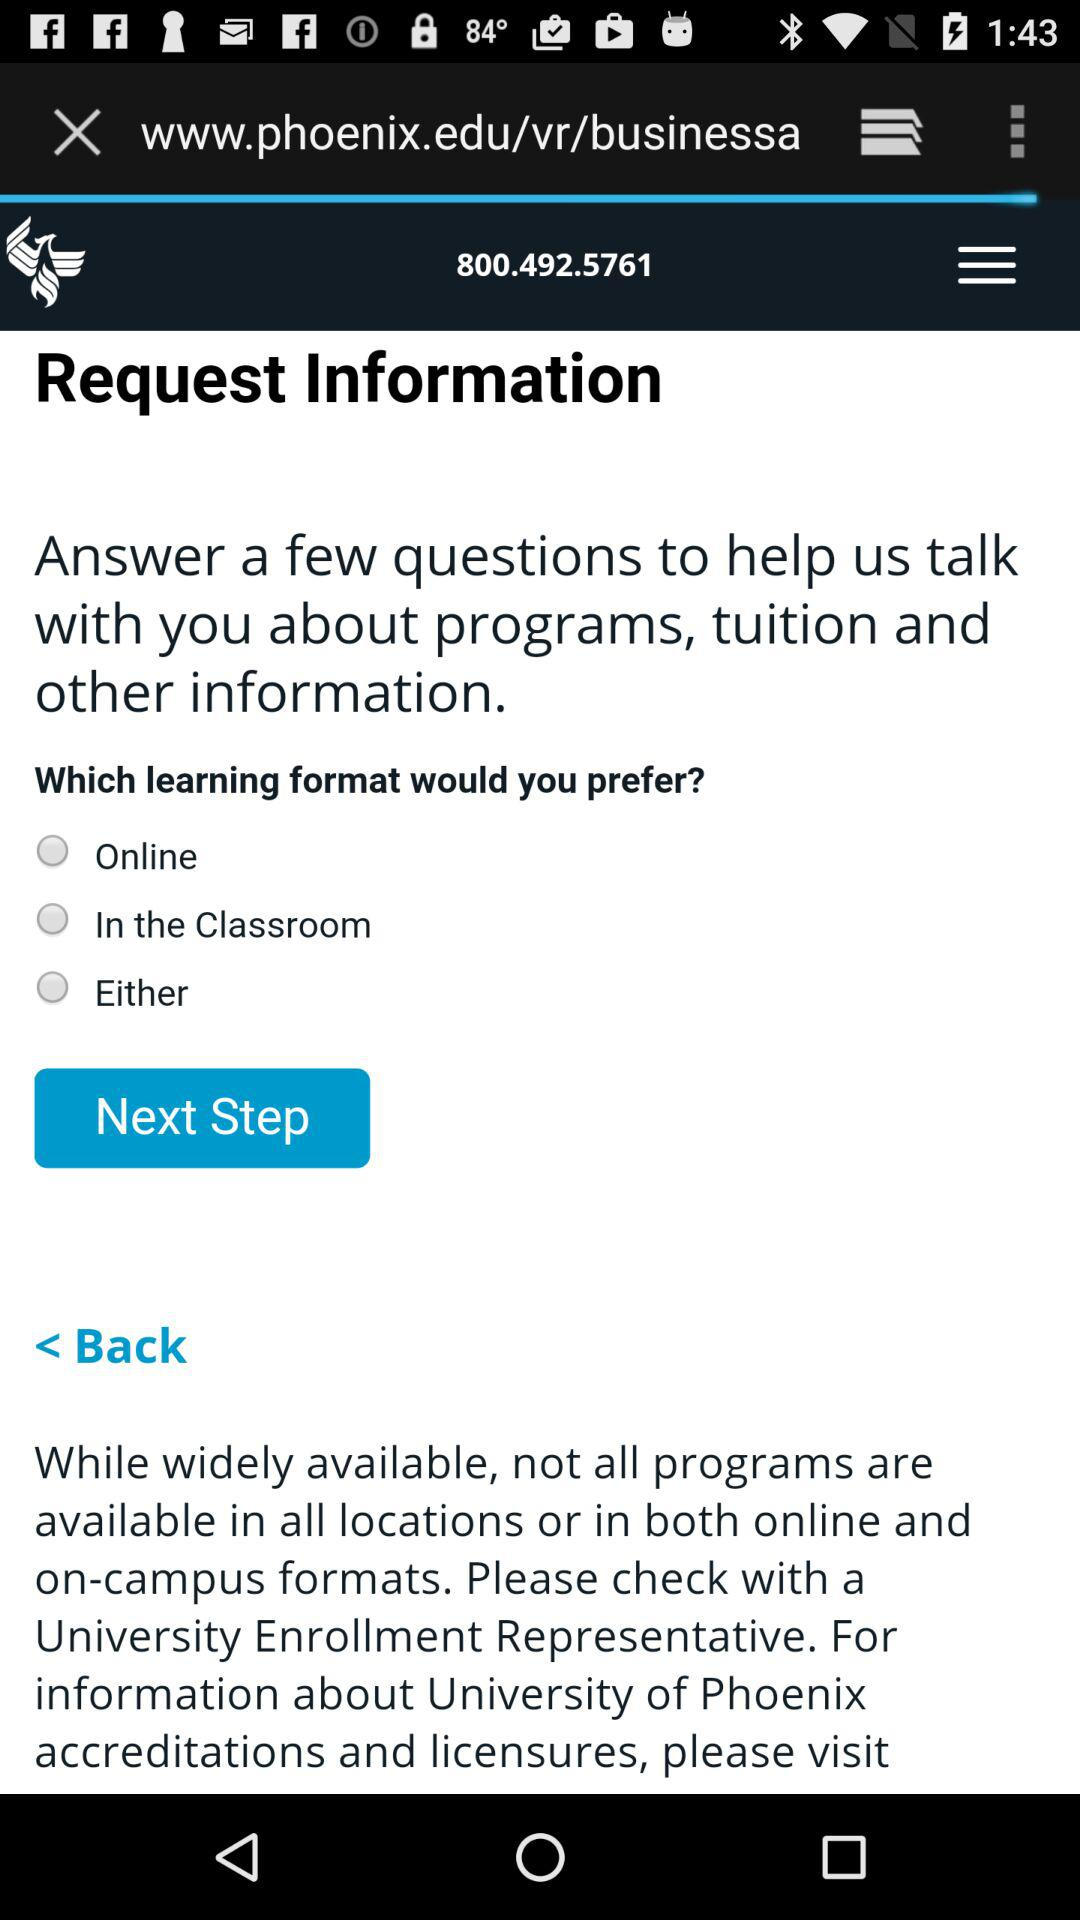How many learning formats are there?
Answer the question using a single word or phrase. 3 